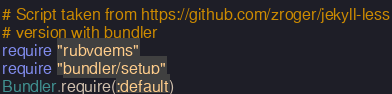Convert code to text. <code><loc_0><loc_0><loc_500><loc_500><_Ruby_># Script taken from https://github.com/zroger/jekyll-less
# version with bundler
require "rubygems"
require "bundler/setup"
Bundler.require(:default)
</code> 